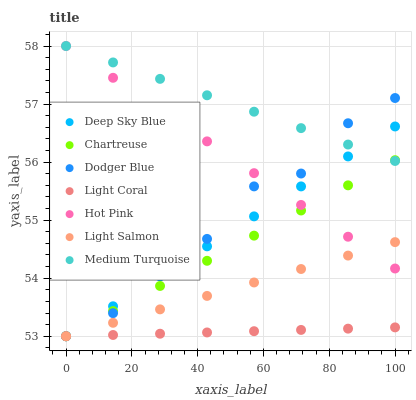Does Light Coral have the minimum area under the curve?
Answer yes or no. Yes. Does Medium Turquoise have the maximum area under the curve?
Answer yes or no. Yes. Does Hot Pink have the minimum area under the curve?
Answer yes or no. No. Does Hot Pink have the maximum area under the curve?
Answer yes or no. No. Is Medium Turquoise the smoothest?
Answer yes or no. Yes. Is Dodger Blue the roughest?
Answer yes or no. Yes. Is Hot Pink the smoothest?
Answer yes or no. No. Is Hot Pink the roughest?
Answer yes or no. No. Does Light Salmon have the lowest value?
Answer yes or no. Yes. Does Hot Pink have the lowest value?
Answer yes or no. No. Does Hot Pink have the highest value?
Answer yes or no. Yes. Does Light Coral have the highest value?
Answer yes or no. No. Is Light Salmon less than Medium Turquoise?
Answer yes or no. Yes. Is Medium Turquoise greater than Light Coral?
Answer yes or no. Yes. Does Light Coral intersect Deep Sky Blue?
Answer yes or no. Yes. Is Light Coral less than Deep Sky Blue?
Answer yes or no. No. Is Light Coral greater than Deep Sky Blue?
Answer yes or no. No. Does Light Salmon intersect Medium Turquoise?
Answer yes or no. No. 